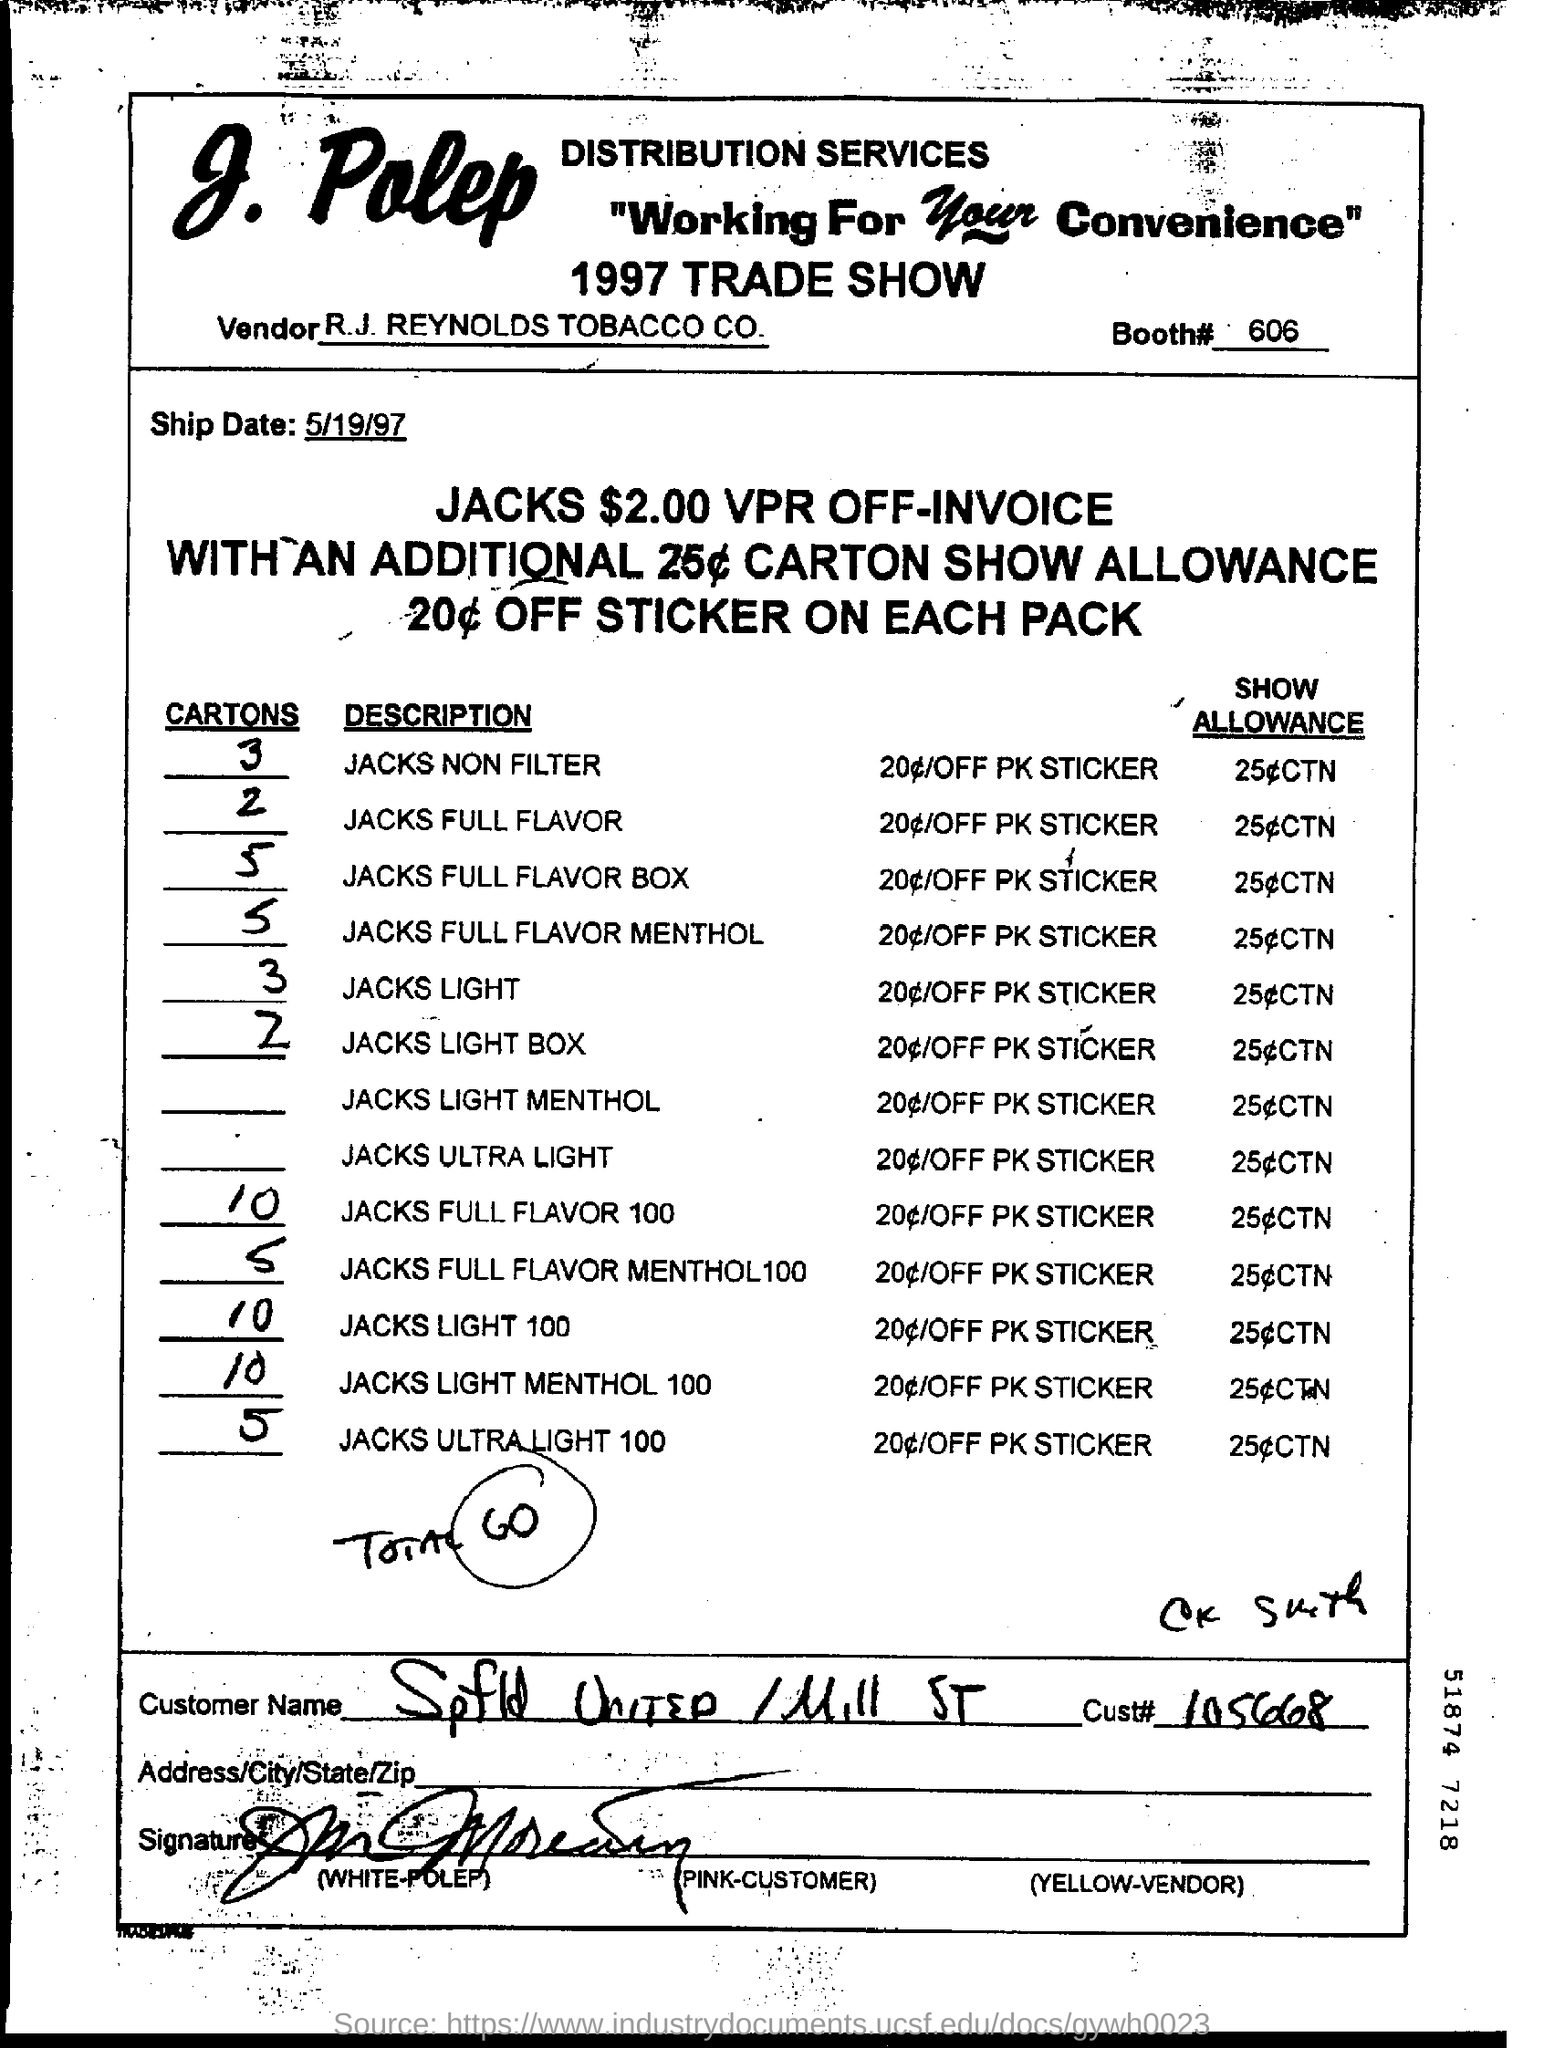Outline some significant characteristics in this image. The ship date is May 19, 1997. The Cust# is 105668... The vendor name is R.J. REYNOLDS TOBACCO CO. The booth number is 606. 